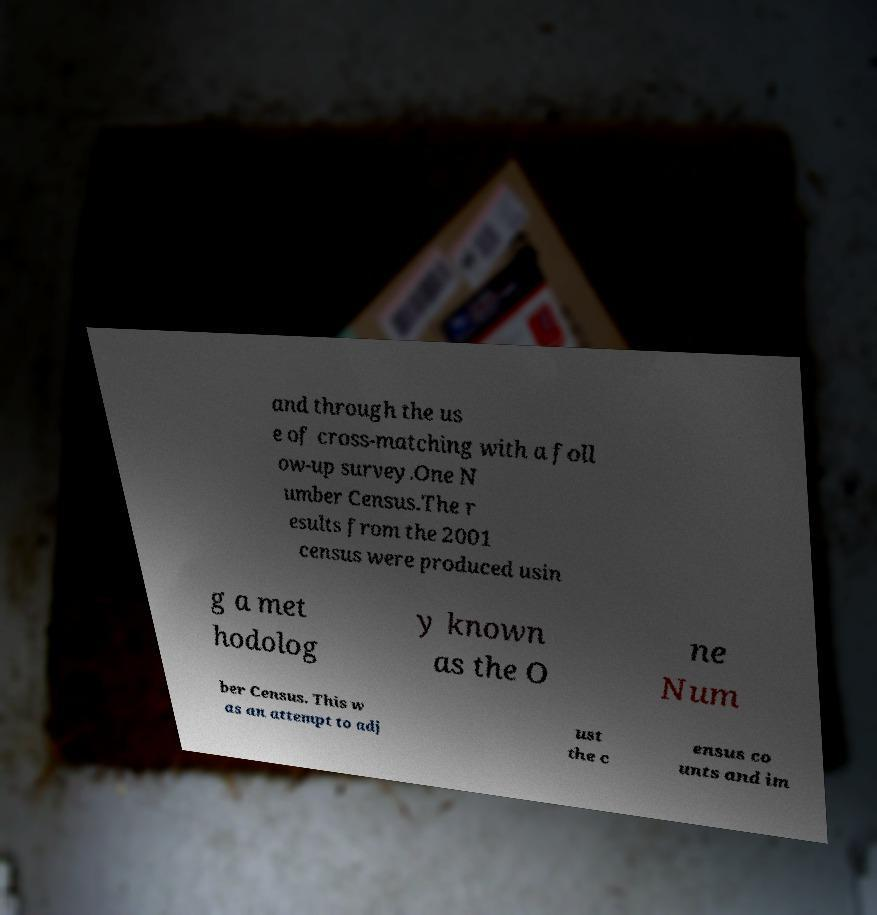Can you accurately transcribe the text from the provided image for me? and through the us e of cross-matching with a foll ow-up survey.One N umber Census.The r esults from the 2001 census were produced usin g a met hodolog y known as the O ne Num ber Census. This w as an attempt to adj ust the c ensus co unts and im 